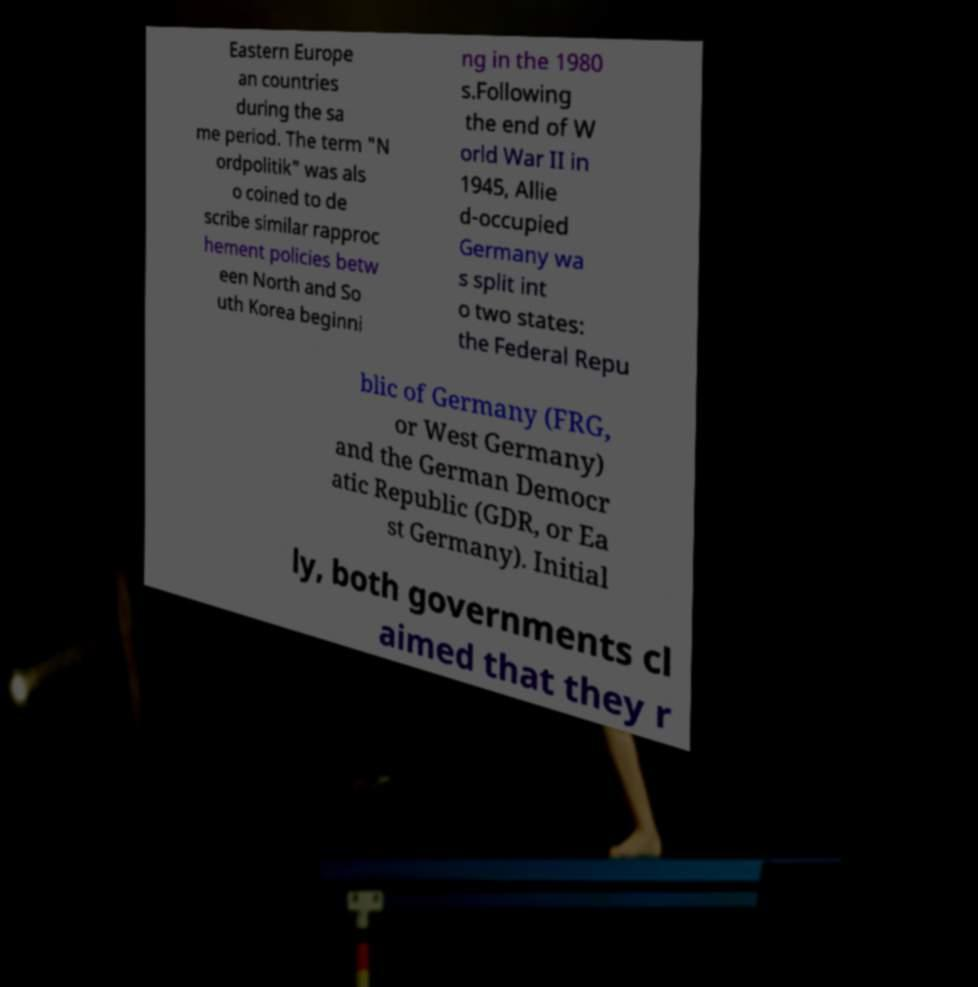Please identify and transcribe the text found in this image. Eastern Europe an countries during the sa me period. The term "N ordpolitik" was als o coined to de scribe similar rapproc hement policies betw een North and So uth Korea beginni ng in the 1980 s.Following the end of W orld War II in 1945, Allie d-occupied Germany wa s split int o two states: the Federal Repu blic of Germany (FRG, or West Germany) and the German Democr atic Republic (GDR, or Ea st Germany). Initial ly, both governments cl aimed that they r 